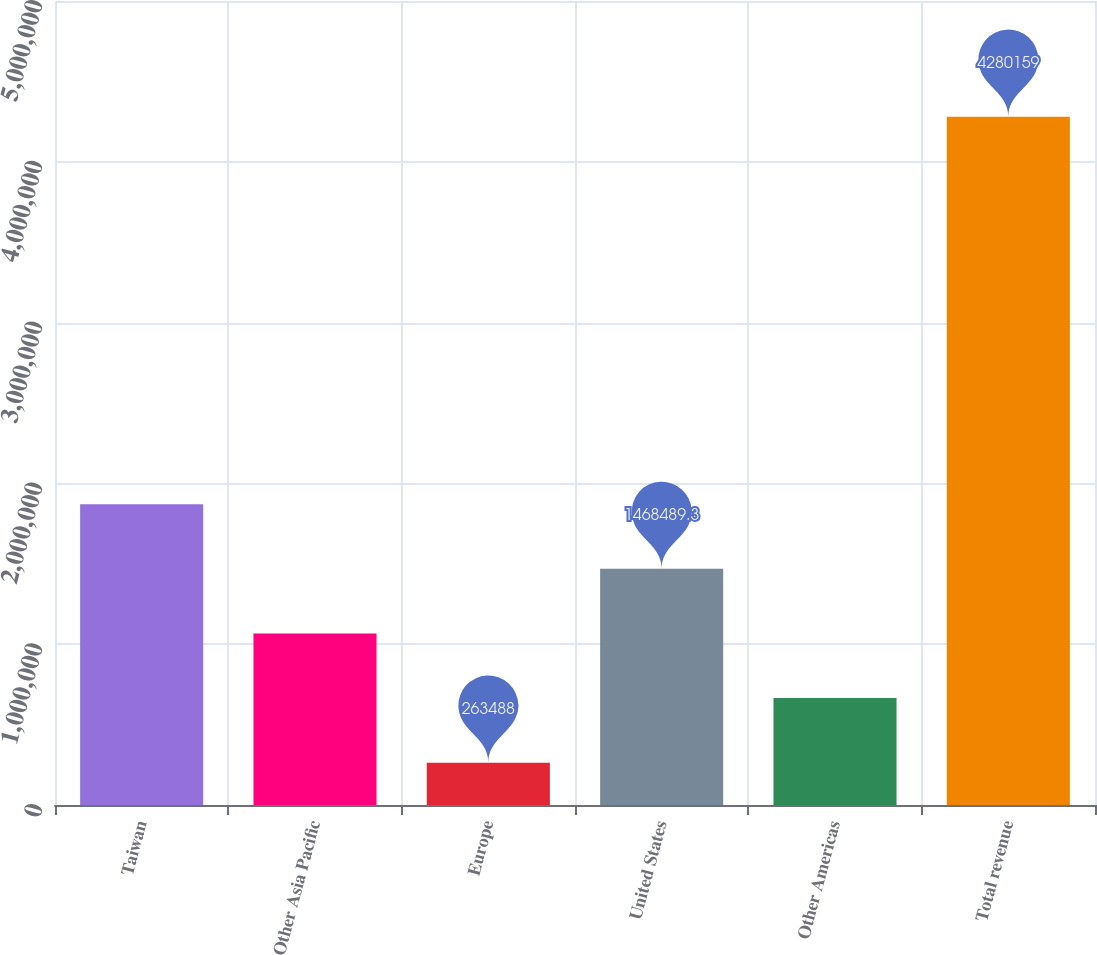Convert chart to OTSL. <chart><loc_0><loc_0><loc_500><loc_500><bar_chart><fcel>Taiwan<fcel>Other Asia Pacific<fcel>Europe<fcel>United States<fcel>Other Americas<fcel>Total revenue<nl><fcel>1.87016e+06<fcel>1.06682e+06<fcel>263488<fcel>1.46849e+06<fcel>665155<fcel>4.28016e+06<nl></chart> 